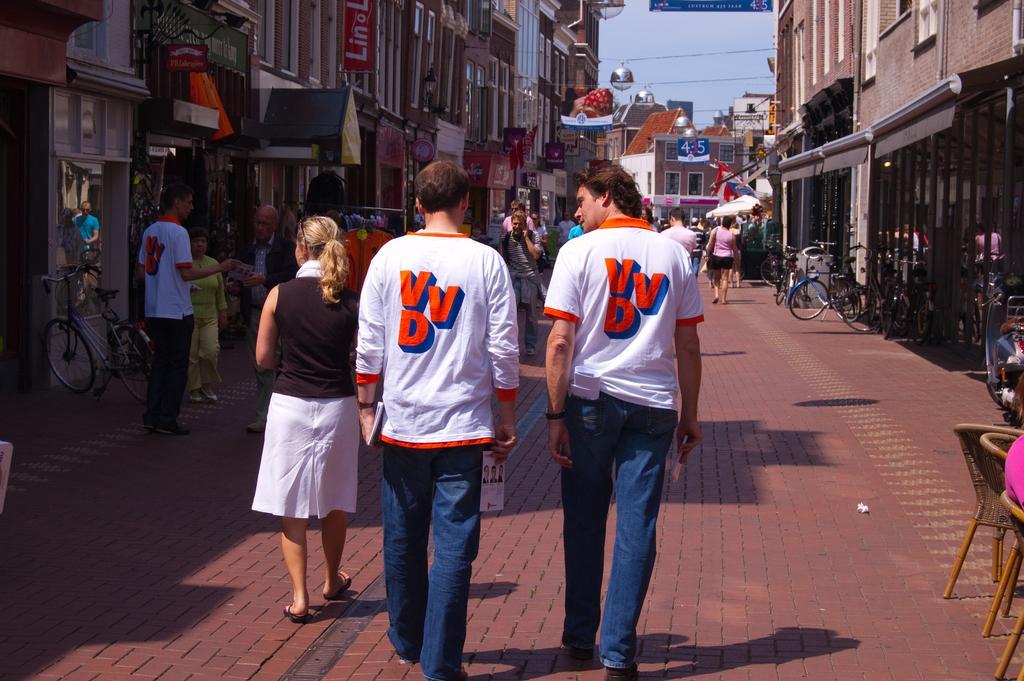Can you describe this image briefly? In this image we can see a group of people on the ground. In that a person is holding the books. We can also see a group of buildings, the flag, some vehicles parked aside, sign boards with some text on them and the sky. On the right side we can see a person sitting on a chair. 